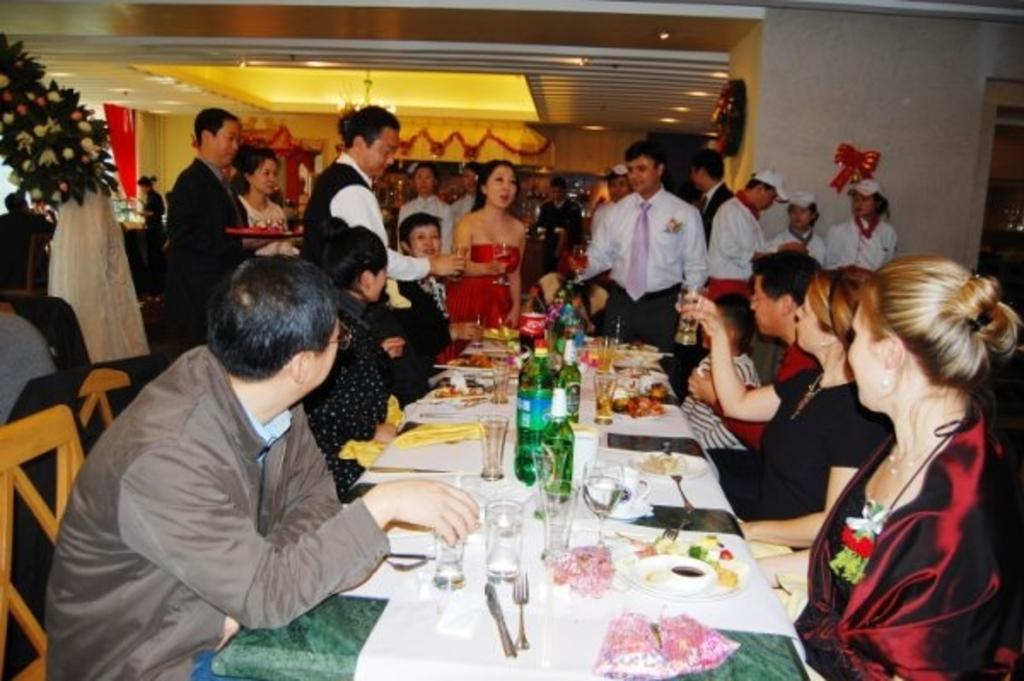In one or two sentences, can you explain what this image depicts? In this image I can see the group of people. Among them some people are sitting in front of the table and some people are standing. On the table there are glasses,bottles,spoons,plates. In the background there is a flower vase and the curtains. 